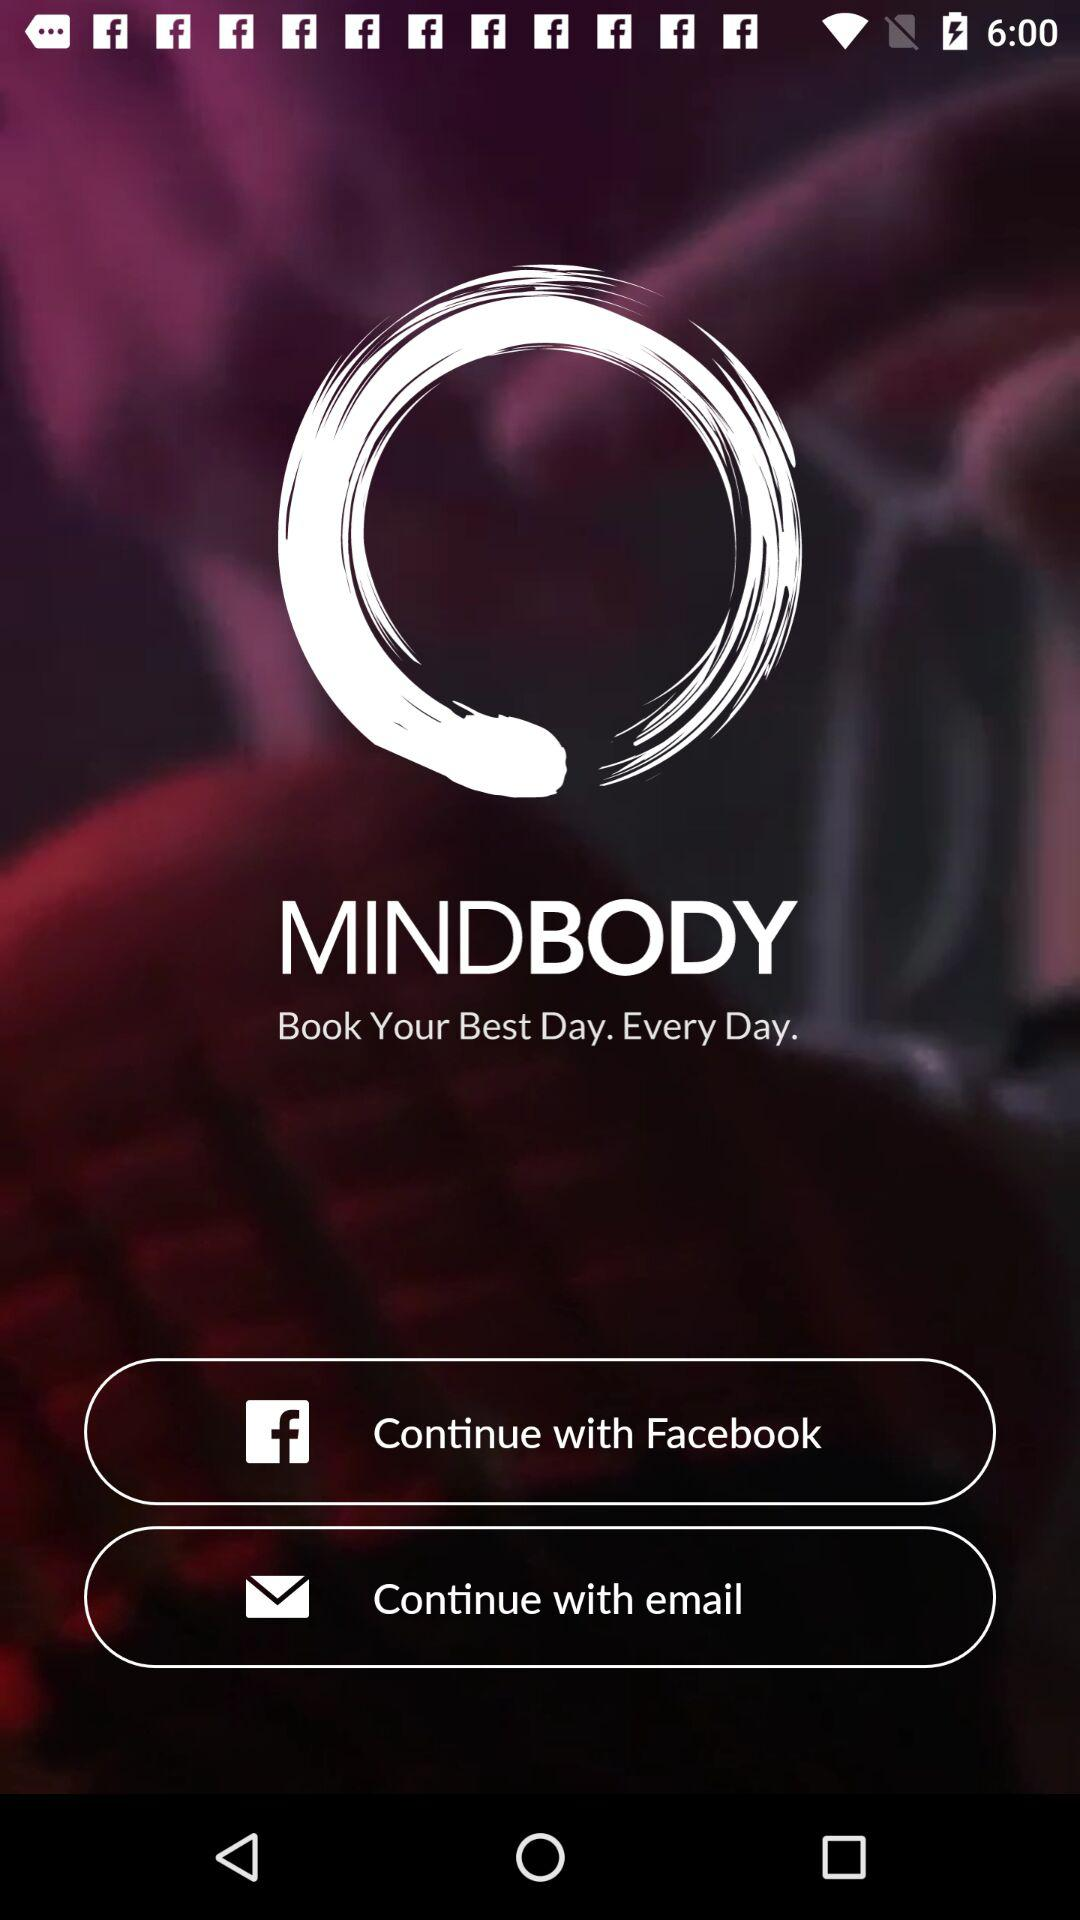What is the name of the application? The name of the application is "MINDBODY". 